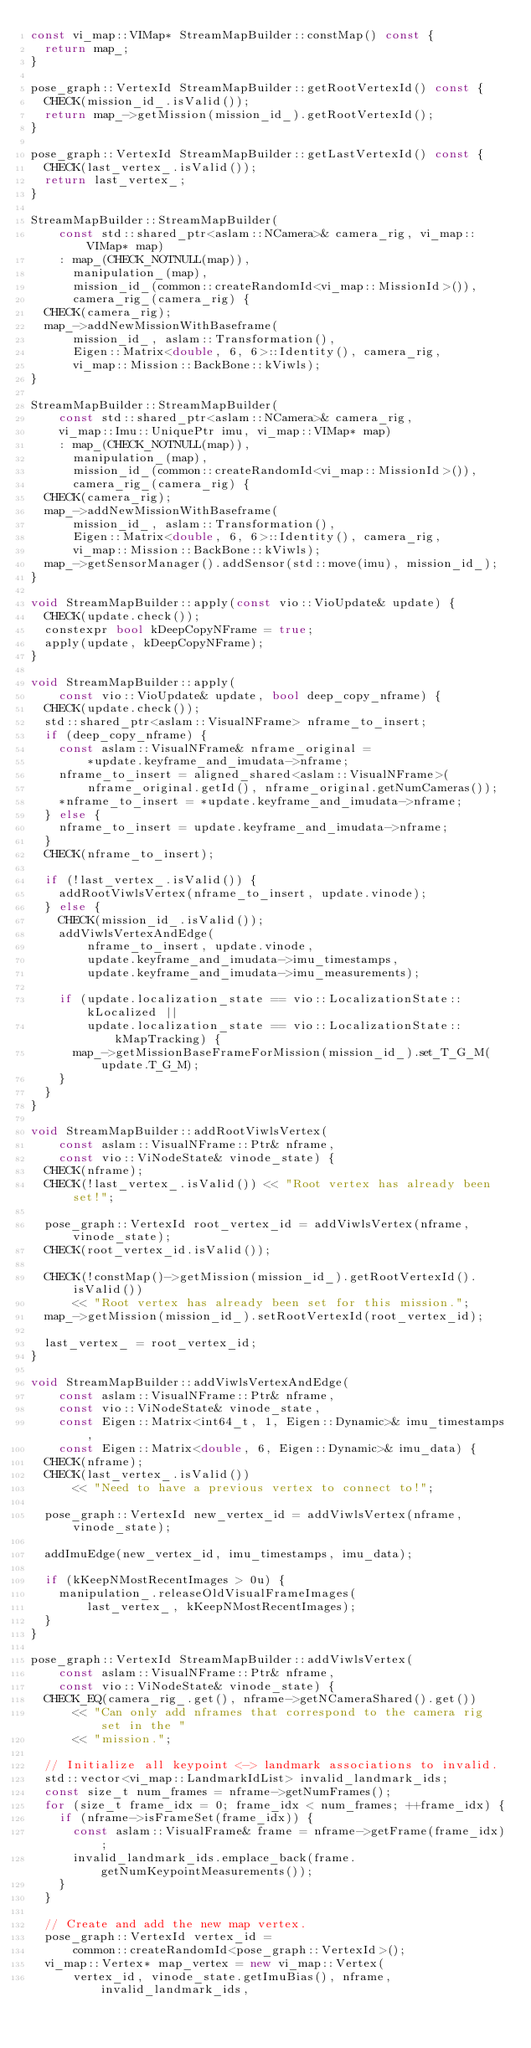Convert code to text. <code><loc_0><loc_0><loc_500><loc_500><_C++_>const vi_map::VIMap* StreamMapBuilder::constMap() const {
  return map_;
}

pose_graph::VertexId StreamMapBuilder::getRootVertexId() const {
  CHECK(mission_id_.isValid());
  return map_->getMission(mission_id_).getRootVertexId();
}

pose_graph::VertexId StreamMapBuilder::getLastVertexId() const {
  CHECK(last_vertex_.isValid());
  return last_vertex_;
}

StreamMapBuilder::StreamMapBuilder(
    const std::shared_ptr<aslam::NCamera>& camera_rig, vi_map::VIMap* map)
    : map_(CHECK_NOTNULL(map)),
      manipulation_(map),
      mission_id_(common::createRandomId<vi_map::MissionId>()),
      camera_rig_(camera_rig) {
  CHECK(camera_rig);
  map_->addNewMissionWithBaseframe(
      mission_id_, aslam::Transformation(),
      Eigen::Matrix<double, 6, 6>::Identity(), camera_rig,
      vi_map::Mission::BackBone::kViwls);
}

StreamMapBuilder::StreamMapBuilder(
    const std::shared_ptr<aslam::NCamera>& camera_rig,
    vi_map::Imu::UniquePtr imu, vi_map::VIMap* map)
    : map_(CHECK_NOTNULL(map)),
      manipulation_(map),
      mission_id_(common::createRandomId<vi_map::MissionId>()),
      camera_rig_(camera_rig) {
  CHECK(camera_rig);
  map_->addNewMissionWithBaseframe(
      mission_id_, aslam::Transformation(),
      Eigen::Matrix<double, 6, 6>::Identity(), camera_rig,
      vi_map::Mission::BackBone::kViwls);
  map_->getSensorManager().addSensor(std::move(imu), mission_id_);
}

void StreamMapBuilder::apply(const vio::VioUpdate& update) {
  CHECK(update.check());
  constexpr bool kDeepCopyNFrame = true;
  apply(update, kDeepCopyNFrame);
}

void StreamMapBuilder::apply(
    const vio::VioUpdate& update, bool deep_copy_nframe) {
  CHECK(update.check());
  std::shared_ptr<aslam::VisualNFrame> nframe_to_insert;
  if (deep_copy_nframe) {
    const aslam::VisualNFrame& nframe_original =
        *update.keyframe_and_imudata->nframe;
    nframe_to_insert = aligned_shared<aslam::VisualNFrame>(
        nframe_original.getId(), nframe_original.getNumCameras());
    *nframe_to_insert = *update.keyframe_and_imudata->nframe;
  } else {
    nframe_to_insert = update.keyframe_and_imudata->nframe;
  }
  CHECK(nframe_to_insert);

  if (!last_vertex_.isValid()) {
    addRootViwlsVertex(nframe_to_insert, update.vinode);
  } else {
    CHECK(mission_id_.isValid());
    addViwlsVertexAndEdge(
        nframe_to_insert, update.vinode,
        update.keyframe_and_imudata->imu_timestamps,
        update.keyframe_and_imudata->imu_measurements);

    if (update.localization_state == vio::LocalizationState::kLocalized ||
        update.localization_state == vio::LocalizationState::kMapTracking) {
      map_->getMissionBaseFrameForMission(mission_id_).set_T_G_M(update.T_G_M);
    }
  }
}

void StreamMapBuilder::addRootViwlsVertex(
    const aslam::VisualNFrame::Ptr& nframe,
    const vio::ViNodeState& vinode_state) {
  CHECK(nframe);
  CHECK(!last_vertex_.isValid()) << "Root vertex has already been set!";

  pose_graph::VertexId root_vertex_id = addViwlsVertex(nframe, vinode_state);
  CHECK(root_vertex_id.isValid());

  CHECK(!constMap()->getMission(mission_id_).getRootVertexId().isValid())
      << "Root vertex has already been set for this mission.";
  map_->getMission(mission_id_).setRootVertexId(root_vertex_id);

  last_vertex_ = root_vertex_id;
}

void StreamMapBuilder::addViwlsVertexAndEdge(
    const aslam::VisualNFrame::Ptr& nframe,
    const vio::ViNodeState& vinode_state,
    const Eigen::Matrix<int64_t, 1, Eigen::Dynamic>& imu_timestamps,
    const Eigen::Matrix<double, 6, Eigen::Dynamic>& imu_data) {
  CHECK(nframe);
  CHECK(last_vertex_.isValid())
      << "Need to have a previous vertex to connect to!";

  pose_graph::VertexId new_vertex_id = addViwlsVertex(nframe, vinode_state);

  addImuEdge(new_vertex_id, imu_timestamps, imu_data);

  if (kKeepNMostRecentImages > 0u) {
    manipulation_.releaseOldVisualFrameImages(
        last_vertex_, kKeepNMostRecentImages);
  }
}

pose_graph::VertexId StreamMapBuilder::addViwlsVertex(
    const aslam::VisualNFrame::Ptr& nframe,
    const vio::ViNodeState& vinode_state) {
  CHECK_EQ(camera_rig_.get(), nframe->getNCameraShared().get())
      << "Can only add nframes that correspond to the camera rig set in the "
      << "mission.";

  // Initialize all keypoint <-> landmark associations to invalid.
  std::vector<vi_map::LandmarkIdList> invalid_landmark_ids;
  const size_t num_frames = nframe->getNumFrames();
  for (size_t frame_idx = 0; frame_idx < num_frames; ++frame_idx) {
    if (nframe->isFrameSet(frame_idx)) {
      const aslam::VisualFrame& frame = nframe->getFrame(frame_idx);
      invalid_landmark_ids.emplace_back(frame.getNumKeypointMeasurements());
    }
  }

  // Create and add the new map vertex.
  pose_graph::VertexId vertex_id =
      common::createRandomId<pose_graph::VertexId>();
  vi_map::Vertex* map_vertex = new vi_map::Vertex(
      vertex_id, vinode_state.getImuBias(), nframe, invalid_landmark_ids,</code> 